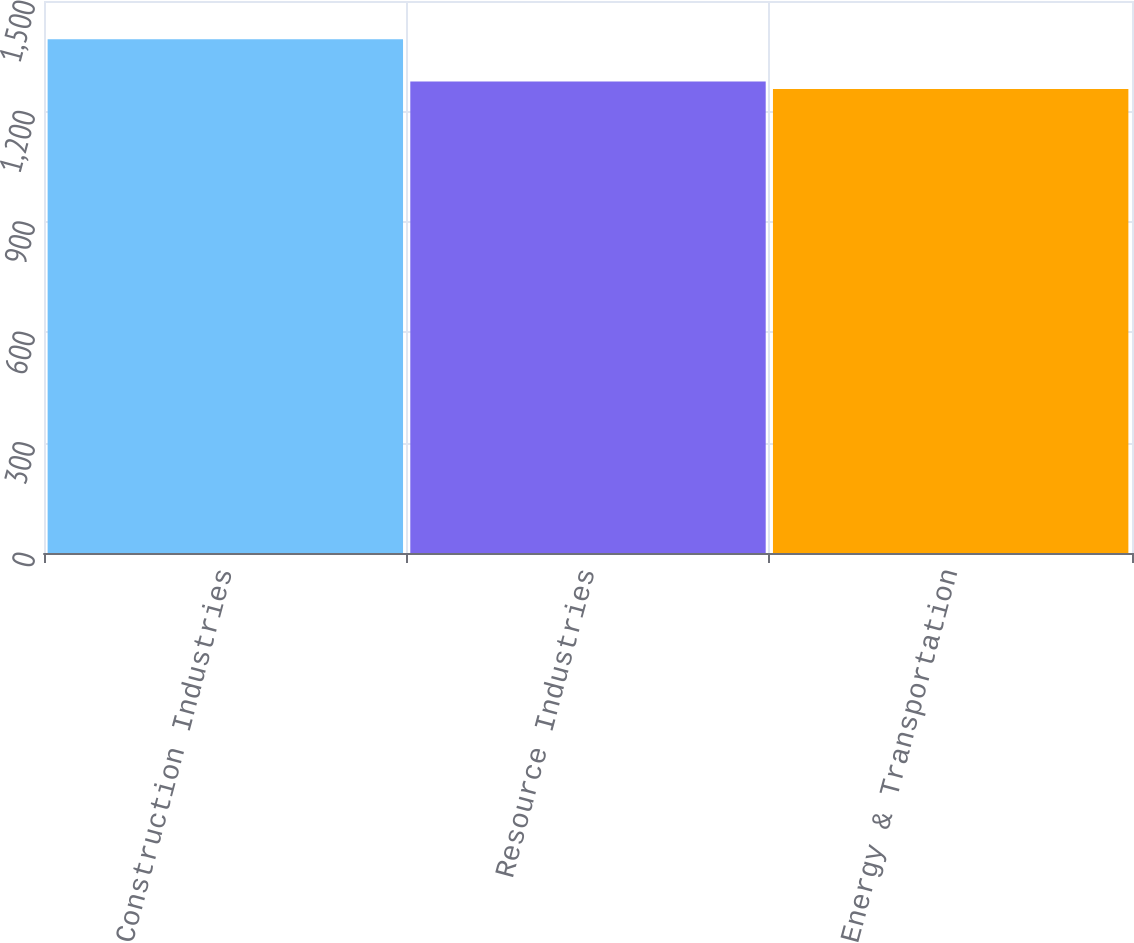Convert chart. <chart><loc_0><loc_0><loc_500><loc_500><bar_chart><fcel>Construction Industries<fcel>Resource Industries<fcel>Energy & Transportation<nl><fcel>1396<fcel>1281<fcel>1261<nl></chart> 